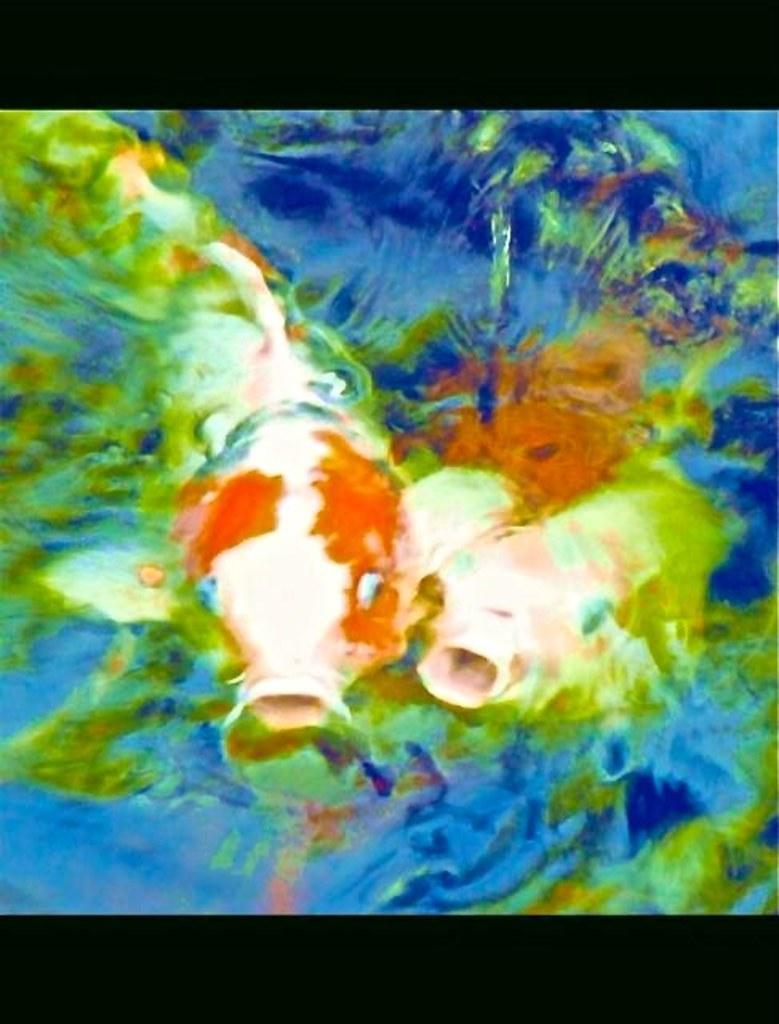In one or two sentences, can you explain what this image depicts? In this image, we can see two fishes in the water. At the top and bottom of the image, we can see black color border. 